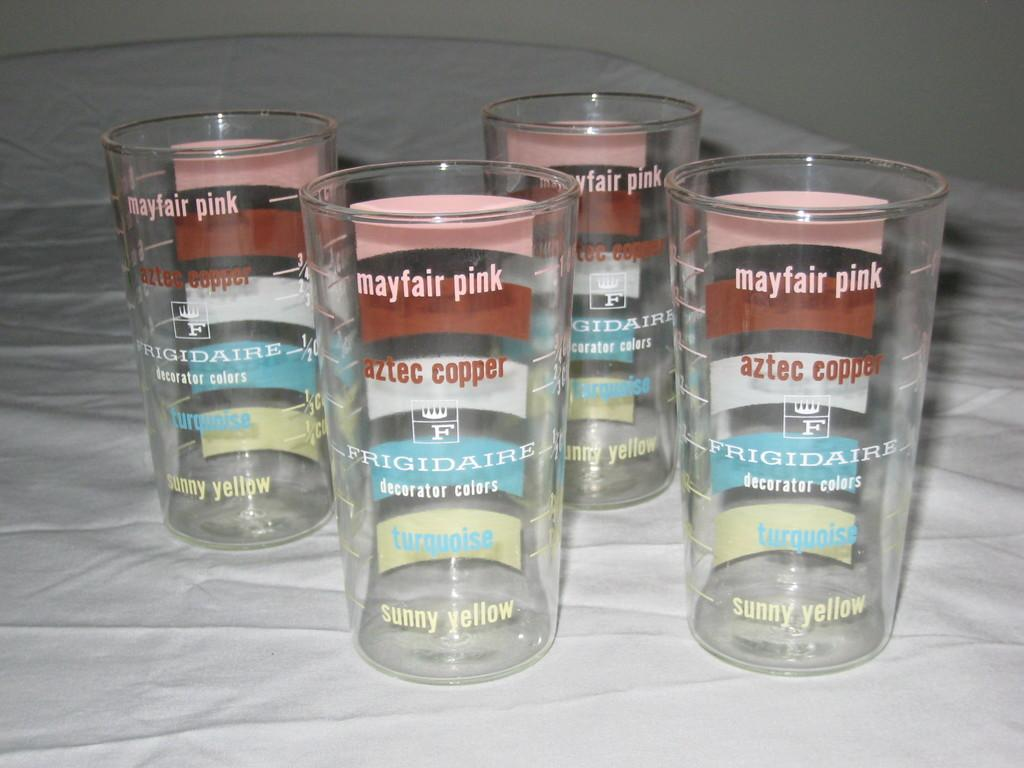<image>
Share a concise interpretation of the image provided. Frigidaire has put decorator colors on the glasses. 